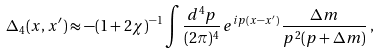Convert formula to latex. <formula><loc_0><loc_0><loc_500><loc_500>\Delta _ { 4 } ( x , x ^ { \prime } ) \approx - ( 1 + 2 \chi ) ^ { - 1 } \int \frac { d ^ { 4 } p } { ( 2 \pi ) ^ { 4 } } \, e ^ { i p ( x - x ^ { \prime } ) } \, \frac { \Delta m } { p ^ { 2 } ( p + \Delta m ) } \, ,</formula> 